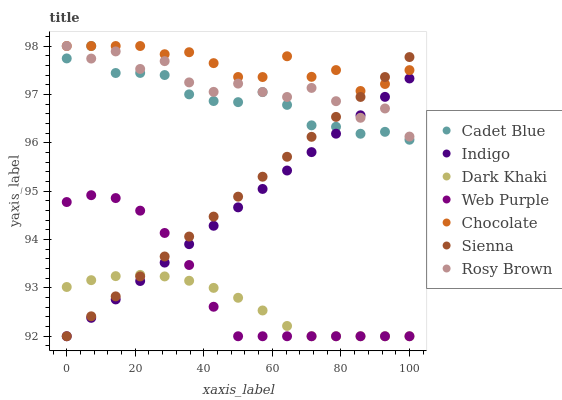Does Dark Khaki have the minimum area under the curve?
Answer yes or no. Yes. Does Chocolate have the maximum area under the curve?
Answer yes or no. Yes. Does Cadet Blue have the minimum area under the curve?
Answer yes or no. No. Does Cadet Blue have the maximum area under the curve?
Answer yes or no. No. Is Sienna the smoothest?
Answer yes or no. Yes. Is Rosy Brown the roughest?
Answer yes or no. Yes. Is Cadet Blue the smoothest?
Answer yes or no. No. Is Cadet Blue the roughest?
Answer yes or no. No. Does Sienna have the lowest value?
Answer yes or no. Yes. Does Cadet Blue have the lowest value?
Answer yes or no. No. Does Chocolate have the highest value?
Answer yes or no. Yes. Does Indigo have the highest value?
Answer yes or no. No. Is Web Purple less than Rosy Brown?
Answer yes or no. Yes. Is Chocolate greater than Web Purple?
Answer yes or no. Yes. Does Rosy Brown intersect Indigo?
Answer yes or no. Yes. Is Rosy Brown less than Indigo?
Answer yes or no. No. Is Rosy Brown greater than Indigo?
Answer yes or no. No. Does Web Purple intersect Rosy Brown?
Answer yes or no. No. 